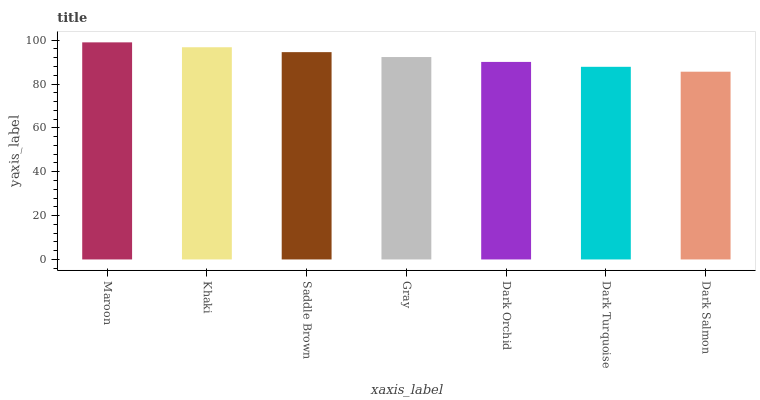Is Dark Salmon the minimum?
Answer yes or no. Yes. Is Maroon the maximum?
Answer yes or no. Yes. Is Khaki the minimum?
Answer yes or no. No. Is Khaki the maximum?
Answer yes or no. No. Is Maroon greater than Khaki?
Answer yes or no. Yes. Is Khaki less than Maroon?
Answer yes or no. Yes. Is Khaki greater than Maroon?
Answer yes or no. No. Is Maroon less than Khaki?
Answer yes or no. No. Is Gray the high median?
Answer yes or no. Yes. Is Gray the low median?
Answer yes or no. Yes. Is Khaki the high median?
Answer yes or no. No. Is Maroon the low median?
Answer yes or no. No. 